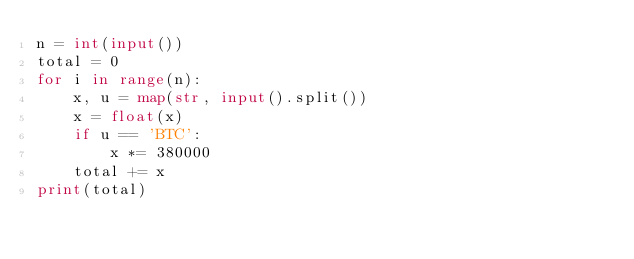<code> <loc_0><loc_0><loc_500><loc_500><_Python_>n = int(input())
total = 0
for i in range(n):
    x, u = map(str, input().split())
    x = float(x)
    if u == 'BTC':
        x *= 380000
    total += x
print(total)</code> 